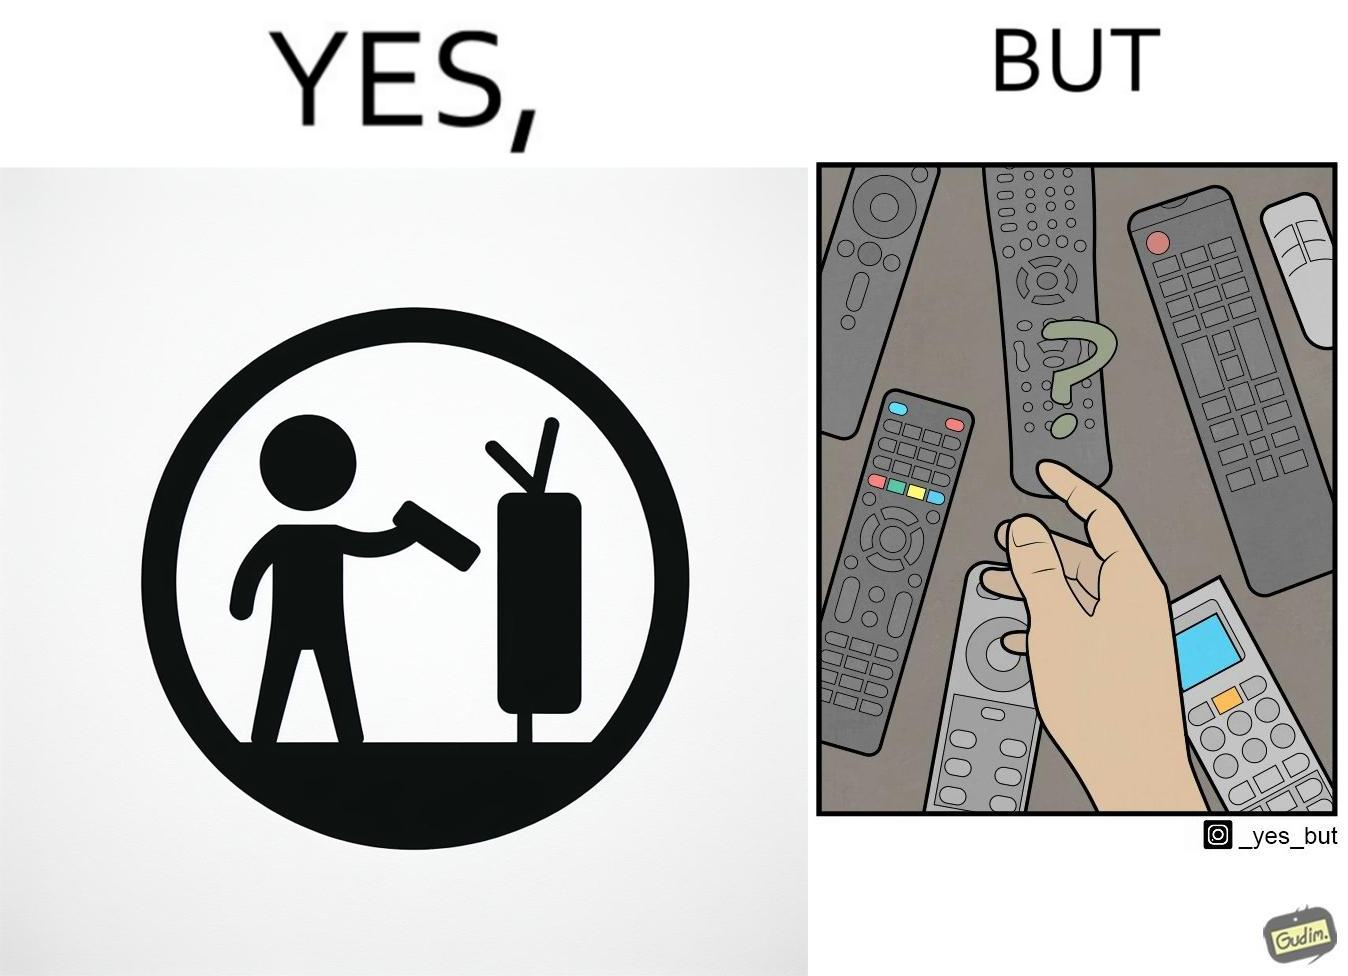What makes this image funny or satirical? The images are funny since they show how even though TV remotes are supposed to make operating TVs easier, having multiple similar looking remotes  for everything only makes it more difficult for the user to use the right one 